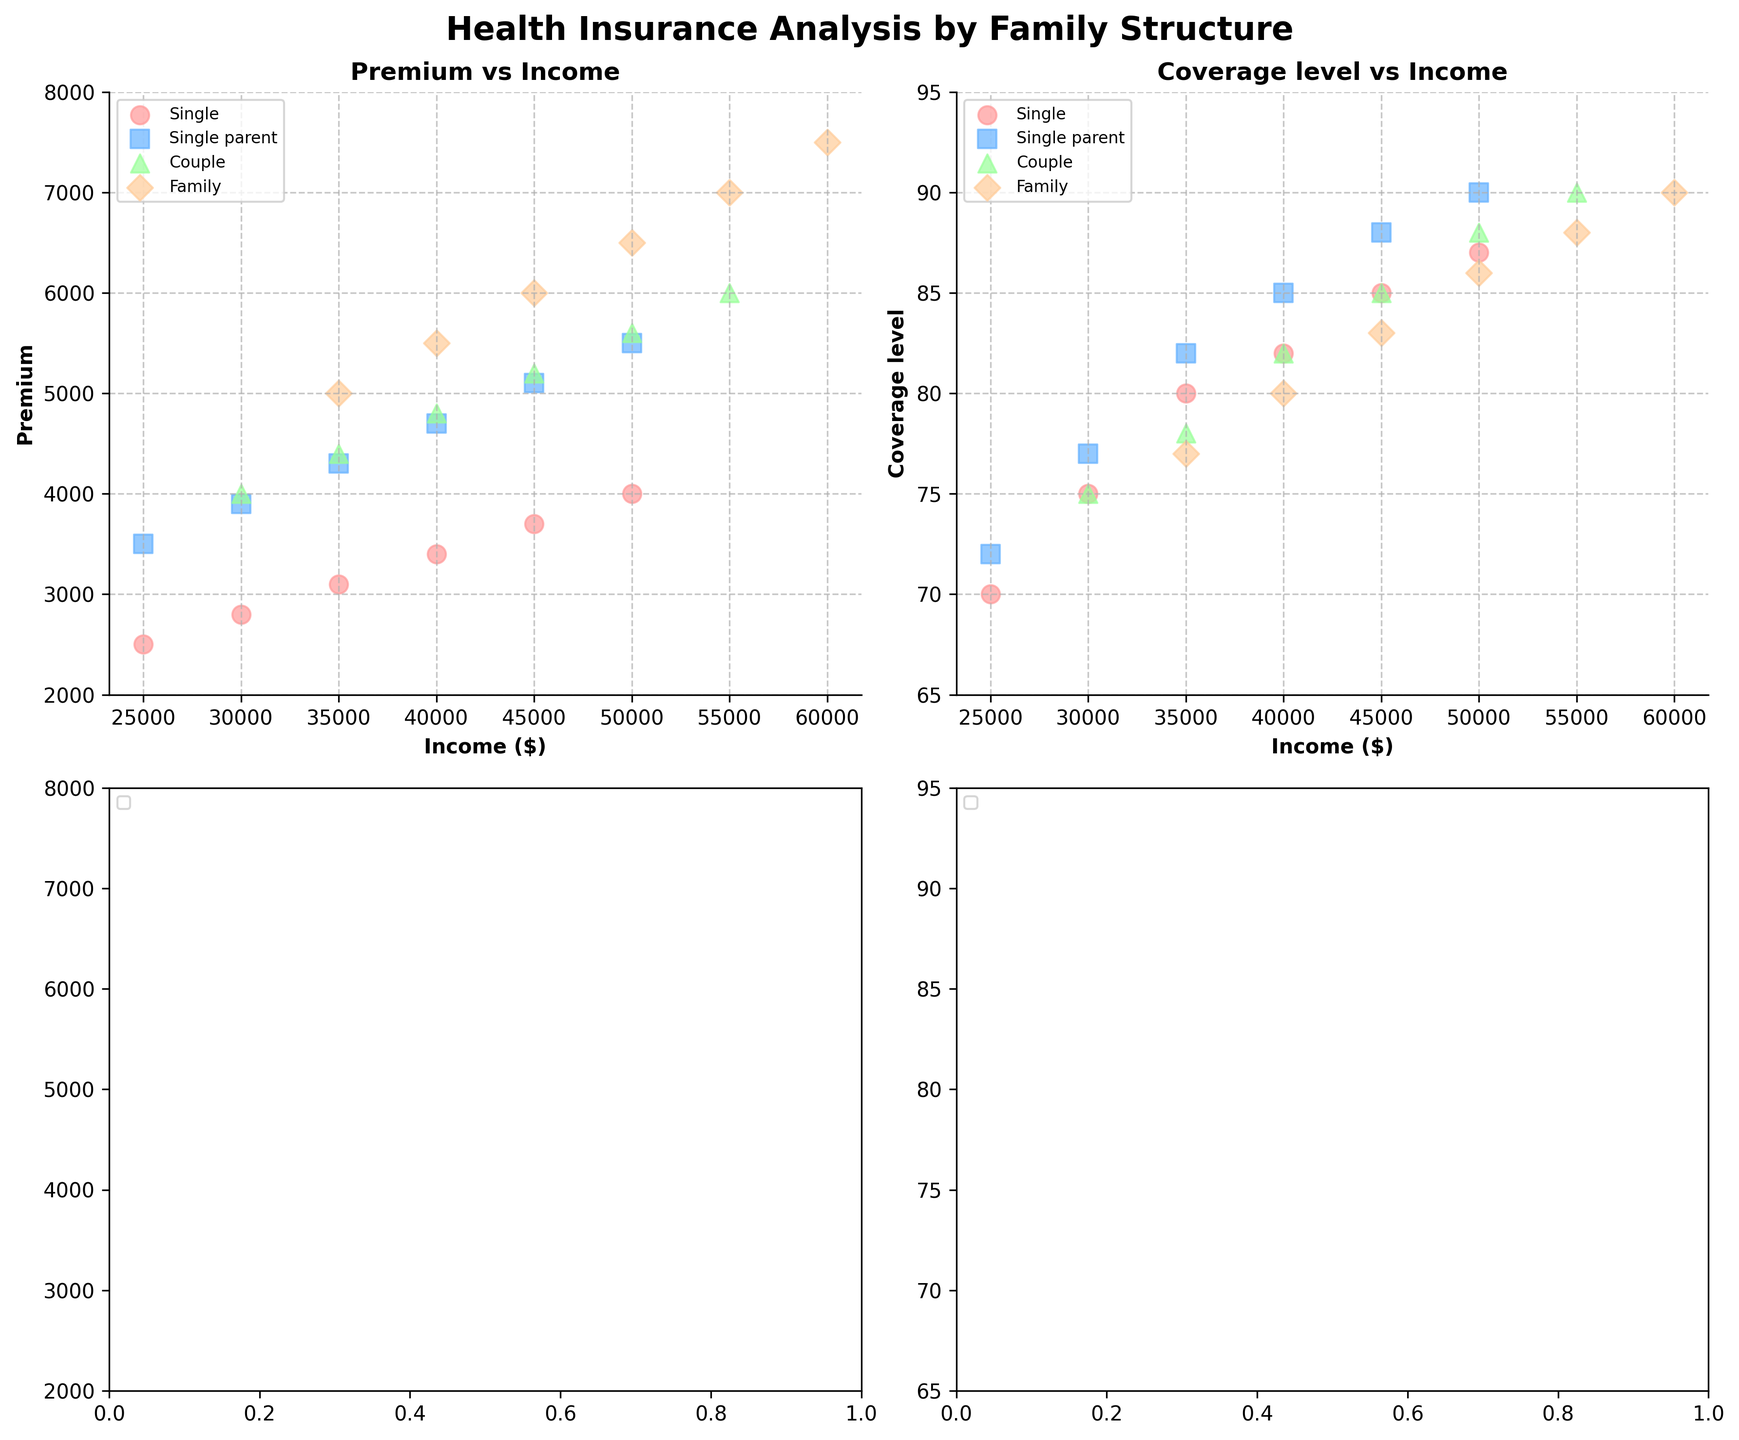What is the trend for insurance premiums as income increases for single-parent families? For each income level, plot the premium for single-parent families. Notice that as income increases from $25,000 to $50,000, the premium also increases, ranging from $3,500 to $5,500.
Answer: Premiums increase What coverage level can a single-parent family expect at an income level of $30,000? Locate the data point for single-parent families at an income of $30,000 on the scatter plot showing coverage levels vs income. The coverage level corresponding to this point is 77.
Answer: 77 Between single-parent and couple families, which has higher premiums at an income of $45,000? Compare the premiums for both family structures at $45,000 income. Single-parent families have a premium of $5,100, while couple families have a premium of $5,200.
Answer: Couple families At an income of $50,000, how much more is the premium for family families compared to single-parent families? Identify the premiums at $50,000 for both family structures. The family premium is $6,500, and the single-parent premium is $5,500. Subtract $5,500 from $6,500.
Answer: $1,000 more What is the range of coverage levels for single families between $25,000 and $50,000 incomes? Identify the coverage levels for single families at the given income range. They start at 70 and increase to 87.
Answer: 70 to 87 Which family structure has the highest coverage level at an income of $50,000? Compare the coverage levels for all family structures at $50,000 income. Family, single-parent, and couple structures all have a coverage level of 90, whereas singles have 87. Therefore, multiple structures can be listed.
Answer: Family, Single-parent, Couple How does the premium for single families at $40,000 compare to the premium for single-parent families at the same income level? Find the premiums for both family types at $40,000. Single families have a premium of $3,400, while single-parent families have $4,700.
Answer: Single-parent premiums are higher Do family structures with higher incomes always result in higher premiums across all categories? Evaluate the trend of premiums for all family structures as income increases. They consistently increase, indicating a direct correlation between income and premium amount.
Answer: Yes Is the trend of increasing coverage levels consistent across different family structures as income rises? Analyze the scatter plots for coverage levels vs income for each family structure. For single, single-parent, couple, and family structures, the coverage level generally increases as income increases.
Answer: Yes 